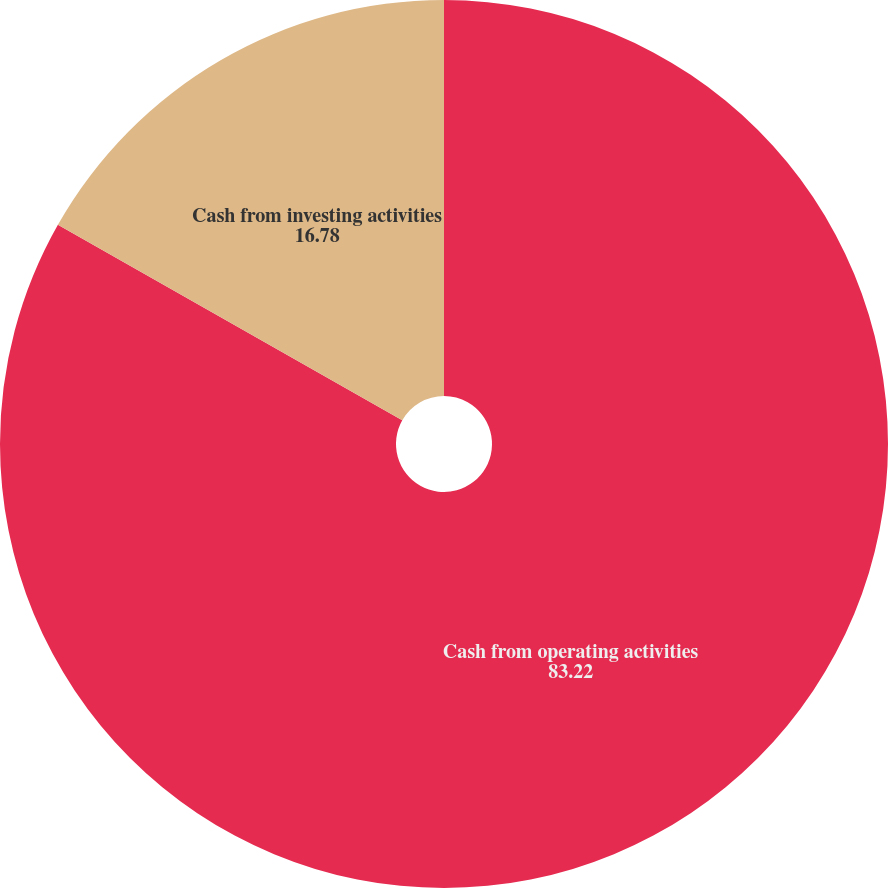Convert chart to OTSL. <chart><loc_0><loc_0><loc_500><loc_500><pie_chart><fcel>Cash from operating activities<fcel>Cash from investing activities<nl><fcel>83.22%<fcel>16.78%<nl></chart> 